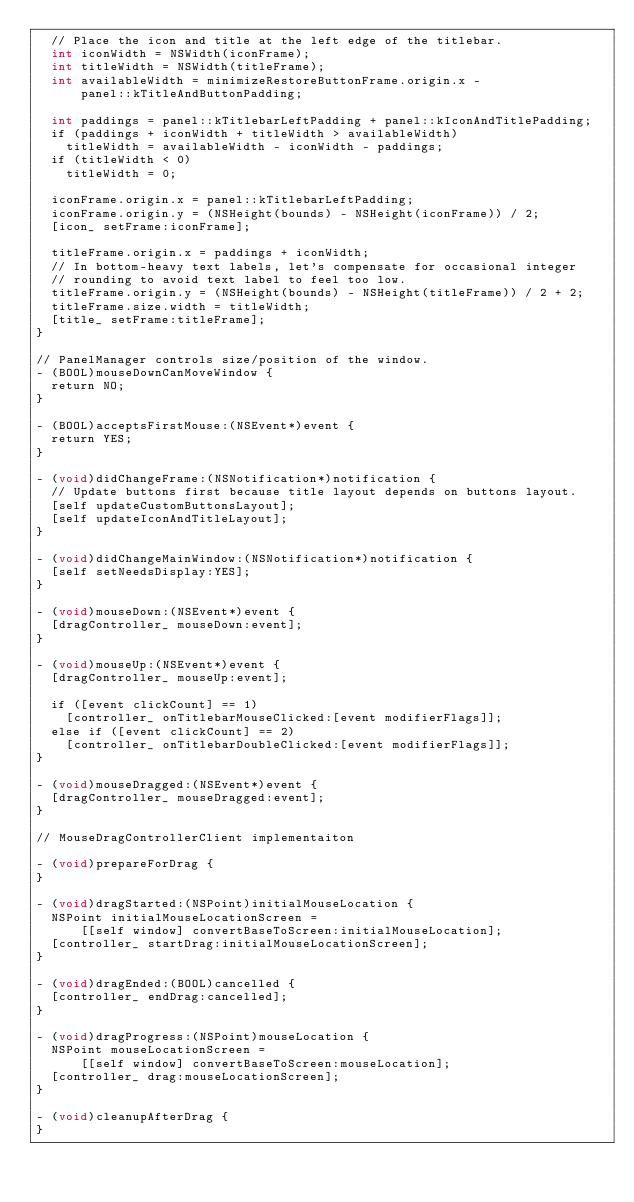<code> <loc_0><loc_0><loc_500><loc_500><_ObjectiveC_>  // Place the icon and title at the left edge of the titlebar.
  int iconWidth = NSWidth(iconFrame);
  int titleWidth = NSWidth(titleFrame);
  int availableWidth = minimizeRestoreButtonFrame.origin.x -
      panel::kTitleAndButtonPadding;

  int paddings = panel::kTitlebarLeftPadding + panel::kIconAndTitlePadding;
  if (paddings + iconWidth + titleWidth > availableWidth)
    titleWidth = availableWidth - iconWidth - paddings;
  if (titleWidth < 0)
    titleWidth = 0;

  iconFrame.origin.x = panel::kTitlebarLeftPadding;
  iconFrame.origin.y = (NSHeight(bounds) - NSHeight(iconFrame)) / 2;
  [icon_ setFrame:iconFrame];

  titleFrame.origin.x = paddings + iconWidth;
  // In bottom-heavy text labels, let's compensate for occasional integer
  // rounding to avoid text label to feel too low.
  titleFrame.origin.y = (NSHeight(bounds) - NSHeight(titleFrame)) / 2 + 2;
  titleFrame.size.width = titleWidth;
  [title_ setFrame:titleFrame];
}

// PanelManager controls size/position of the window.
- (BOOL)mouseDownCanMoveWindow {
  return NO;
}

- (BOOL)acceptsFirstMouse:(NSEvent*)event {
  return YES;
}

- (void)didChangeFrame:(NSNotification*)notification {
  // Update buttons first because title layout depends on buttons layout.
  [self updateCustomButtonsLayout];
  [self updateIconAndTitleLayout];
}

- (void)didChangeMainWindow:(NSNotification*)notification {
  [self setNeedsDisplay:YES];
}

- (void)mouseDown:(NSEvent*)event {
  [dragController_ mouseDown:event];
}

- (void)mouseUp:(NSEvent*)event {
  [dragController_ mouseUp:event];

  if ([event clickCount] == 1)
    [controller_ onTitlebarMouseClicked:[event modifierFlags]];
  else if ([event clickCount] == 2)
    [controller_ onTitlebarDoubleClicked:[event modifierFlags]];
}

- (void)mouseDragged:(NSEvent*)event {
  [dragController_ mouseDragged:event];
}

// MouseDragControllerClient implementaiton

- (void)prepareForDrag {
}

- (void)dragStarted:(NSPoint)initialMouseLocation {
  NSPoint initialMouseLocationScreen =
      [[self window] convertBaseToScreen:initialMouseLocation];
  [controller_ startDrag:initialMouseLocationScreen];
}

- (void)dragEnded:(BOOL)cancelled {
  [controller_ endDrag:cancelled];
}

- (void)dragProgress:(NSPoint)mouseLocation {
  NSPoint mouseLocationScreen =
      [[self window] convertBaseToScreen:mouseLocation];
  [controller_ drag:mouseLocationScreen];
}

- (void)cleanupAfterDrag {
}
</code> 